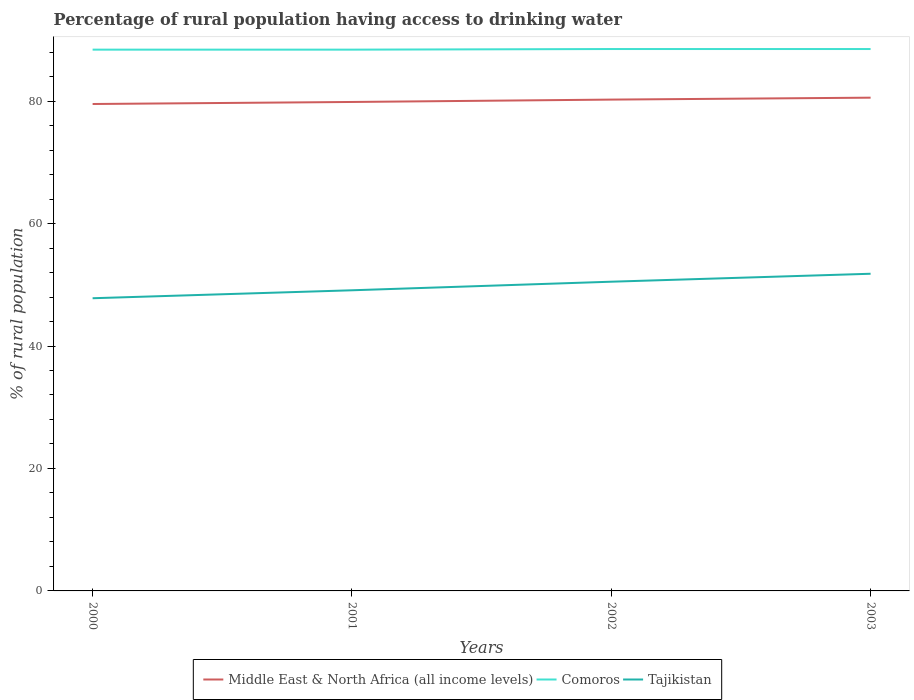Across all years, what is the maximum percentage of rural population having access to drinking water in Comoros?
Provide a succinct answer. 88.4. What is the total percentage of rural population having access to drinking water in Middle East & North Africa (all income levels) in the graph?
Offer a terse response. -0.7. What is the difference between the highest and the second highest percentage of rural population having access to drinking water in Middle East & North Africa (all income levels)?
Offer a terse response. 1.03. Is the percentage of rural population having access to drinking water in Comoros strictly greater than the percentage of rural population having access to drinking water in Middle East & North Africa (all income levels) over the years?
Your response must be concise. No. How many years are there in the graph?
Keep it short and to the point. 4. Are the values on the major ticks of Y-axis written in scientific E-notation?
Make the answer very short. No. Does the graph contain any zero values?
Offer a very short reply. No. Where does the legend appear in the graph?
Give a very brief answer. Bottom center. What is the title of the graph?
Ensure brevity in your answer.  Percentage of rural population having access to drinking water. What is the label or title of the X-axis?
Your answer should be compact. Years. What is the label or title of the Y-axis?
Give a very brief answer. % of rural population. What is the % of rural population of Middle East & North Africa (all income levels) in 2000?
Offer a very short reply. 79.52. What is the % of rural population in Comoros in 2000?
Provide a succinct answer. 88.4. What is the % of rural population in Tajikistan in 2000?
Give a very brief answer. 47.8. What is the % of rural population in Middle East & North Africa (all income levels) in 2001?
Give a very brief answer. 79.86. What is the % of rural population in Comoros in 2001?
Keep it short and to the point. 88.4. What is the % of rural population in Tajikistan in 2001?
Provide a short and direct response. 49.1. What is the % of rural population of Middle East & North Africa (all income levels) in 2002?
Make the answer very short. 80.24. What is the % of rural population of Comoros in 2002?
Your response must be concise. 88.5. What is the % of rural population in Tajikistan in 2002?
Offer a terse response. 50.5. What is the % of rural population of Middle East & North Africa (all income levels) in 2003?
Your answer should be very brief. 80.56. What is the % of rural population in Comoros in 2003?
Your answer should be very brief. 88.5. What is the % of rural population in Tajikistan in 2003?
Ensure brevity in your answer.  51.8. Across all years, what is the maximum % of rural population in Middle East & North Africa (all income levels)?
Ensure brevity in your answer.  80.56. Across all years, what is the maximum % of rural population of Comoros?
Provide a short and direct response. 88.5. Across all years, what is the maximum % of rural population in Tajikistan?
Provide a short and direct response. 51.8. Across all years, what is the minimum % of rural population of Middle East & North Africa (all income levels)?
Give a very brief answer. 79.52. Across all years, what is the minimum % of rural population in Comoros?
Your answer should be very brief. 88.4. Across all years, what is the minimum % of rural population of Tajikistan?
Make the answer very short. 47.8. What is the total % of rural population in Middle East & North Africa (all income levels) in the graph?
Ensure brevity in your answer.  320.18. What is the total % of rural population of Comoros in the graph?
Your answer should be very brief. 353.8. What is the total % of rural population of Tajikistan in the graph?
Provide a short and direct response. 199.2. What is the difference between the % of rural population of Middle East & North Africa (all income levels) in 2000 and that in 2001?
Your answer should be very brief. -0.33. What is the difference between the % of rural population of Tajikistan in 2000 and that in 2001?
Provide a short and direct response. -1.3. What is the difference between the % of rural population in Middle East & North Africa (all income levels) in 2000 and that in 2002?
Provide a succinct answer. -0.72. What is the difference between the % of rural population of Comoros in 2000 and that in 2002?
Give a very brief answer. -0.1. What is the difference between the % of rural population in Middle East & North Africa (all income levels) in 2000 and that in 2003?
Offer a terse response. -1.03. What is the difference between the % of rural population in Tajikistan in 2000 and that in 2003?
Give a very brief answer. -4. What is the difference between the % of rural population in Middle East & North Africa (all income levels) in 2001 and that in 2002?
Your answer should be very brief. -0.39. What is the difference between the % of rural population of Comoros in 2001 and that in 2002?
Keep it short and to the point. -0.1. What is the difference between the % of rural population in Tajikistan in 2001 and that in 2002?
Provide a succinct answer. -1.4. What is the difference between the % of rural population in Middle East & North Africa (all income levels) in 2001 and that in 2003?
Your answer should be very brief. -0.7. What is the difference between the % of rural population in Comoros in 2001 and that in 2003?
Your answer should be very brief. -0.1. What is the difference between the % of rural population of Middle East & North Africa (all income levels) in 2002 and that in 2003?
Keep it short and to the point. -0.31. What is the difference between the % of rural population in Middle East & North Africa (all income levels) in 2000 and the % of rural population in Comoros in 2001?
Give a very brief answer. -8.88. What is the difference between the % of rural population of Middle East & North Africa (all income levels) in 2000 and the % of rural population of Tajikistan in 2001?
Your answer should be very brief. 30.42. What is the difference between the % of rural population of Comoros in 2000 and the % of rural population of Tajikistan in 2001?
Offer a terse response. 39.3. What is the difference between the % of rural population in Middle East & North Africa (all income levels) in 2000 and the % of rural population in Comoros in 2002?
Keep it short and to the point. -8.98. What is the difference between the % of rural population in Middle East & North Africa (all income levels) in 2000 and the % of rural population in Tajikistan in 2002?
Your answer should be very brief. 29.02. What is the difference between the % of rural population in Comoros in 2000 and the % of rural population in Tajikistan in 2002?
Your response must be concise. 37.9. What is the difference between the % of rural population in Middle East & North Africa (all income levels) in 2000 and the % of rural population in Comoros in 2003?
Make the answer very short. -8.98. What is the difference between the % of rural population of Middle East & North Africa (all income levels) in 2000 and the % of rural population of Tajikistan in 2003?
Your answer should be very brief. 27.72. What is the difference between the % of rural population in Comoros in 2000 and the % of rural population in Tajikistan in 2003?
Offer a very short reply. 36.6. What is the difference between the % of rural population of Middle East & North Africa (all income levels) in 2001 and the % of rural population of Comoros in 2002?
Provide a succinct answer. -8.64. What is the difference between the % of rural population of Middle East & North Africa (all income levels) in 2001 and the % of rural population of Tajikistan in 2002?
Offer a terse response. 29.36. What is the difference between the % of rural population of Comoros in 2001 and the % of rural population of Tajikistan in 2002?
Ensure brevity in your answer.  37.9. What is the difference between the % of rural population of Middle East & North Africa (all income levels) in 2001 and the % of rural population of Comoros in 2003?
Make the answer very short. -8.64. What is the difference between the % of rural population in Middle East & North Africa (all income levels) in 2001 and the % of rural population in Tajikistan in 2003?
Your answer should be very brief. 28.06. What is the difference between the % of rural population in Comoros in 2001 and the % of rural population in Tajikistan in 2003?
Give a very brief answer. 36.6. What is the difference between the % of rural population of Middle East & North Africa (all income levels) in 2002 and the % of rural population of Comoros in 2003?
Provide a short and direct response. -8.26. What is the difference between the % of rural population of Middle East & North Africa (all income levels) in 2002 and the % of rural population of Tajikistan in 2003?
Provide a short and direct response. 28.44. What is the difference between the % of rural population in Comoros in 2002 and the % of rural population in Tajikistan in 2003?
Your answer should be compact. 36.7. What is the average % of rural population in Middle East & North Africa (all income levels) per year?
Provide a succinct answer. 80.04. What is the average % of rural population of Comoros per year?
Your answer should be very brief. 88.45. What is the average % of rural population of Tajikistan per year?
Your answer should be compact. 49.8. In the year 2000, what is the difference between the % of rural population of Middle East & North Africa (all income levels) and % of rural population of Comoros?
Keep it short and to the point. -8.88. In the year 2000, what is the difference between the % of rural population of Middle East & North Africa (all income levels) and % of rural population of Tajikistan?
Provide a succinct answer. 31.72. In the year 2000, what is the difference between the % of rural population in Comoros and % of rural population in Tajikistan?
Your answer should be very brief. 40.6. In the year 2001, what is the difference between the % of rural population in Middle East & North Africa (all income levels) and % of rural population in Comoros?
Your answer should be compact. -8.54. In the year 2001, what is the difference between the % of rural population in Middle East & North Africa (all income levels) and % of rural population in Tajikistan?
Your response must be concise. 30.76. In the year 2001, what is the difference between the % of rural population in Comoros and % of rural population in Tajikistan?
Provide a short and direct response. 39.3. In the year 2002, what is the difference between the % of rural population in Middle East & North Africa (all income levels) and % of rural population in Comoros?
Provide a succinct answer. -8.26. In the year 2002, what is the difference between the % of rural population of Middle East & North Africa (all income levels) and % of rural population of Tajikistan?
Keep it short and to the point. 29.74. In the year 2003, what is the difference between the % of rural population in Middle East & North Africa (all income levels) and % of rural population in Comoros?
Your response must be concise. -7.94. In the year 2003, what is the difference between the % of rural population in Middle East & North Africa (all income levels) and % of rural population in Tajikistan?
Provide a succinct answer. 28.76. In the year 2003, what is the difference between the % of rural population of Comoros and % of rural population of Tajikistan?
Ensure brevity in your answer.  36.7. What is the ratio of the % of rural population in Middle East & North Africa (all income levels) in 2000 to that in 2001?
Keep it short and to the point. 1. What is the ratio of the % of rural population of Tajikistan in 2000 to that in 2001?
Give a very brief answer. 0.97. What is the ratio of the % of rural population in Middle East & North Africa (all income levels) in 2000 to that in 2002?
Keep it short and to the point. 0.99. What is the ratio of the % of rural population of Tajikistan in 2000 to that in 2002?
Give a very brief answer. 0.95. What is the ratio of the % of rural population of Middle East & North Africa (all income levels) in 2000 to that in 2003?
Your answer should be very brief. 0.99. What is the ratio of the % of rural population of Comoros in 2000 to that in 2003?
Your response must be concise. 1. What is the ratio of the % of rural population in Tajikistan in 2000 to that in 2003?
Ensure brevity in your answer.  0.92. What is the ratio of the % of rural population of Middle East & North Africa (all income levels) in 2001 to that in 2002?
Provide a succinct answer. 1. What is the ratio of the % of rural population of Tajikistan in 2001 to that in 2002?
Give a very brief answer. 0.97. What is the ratio of the % of rural population in Middle East & North Africa (all income levels) in 2001 to that in 2003?
Your answer should be compact. 0.99. What is the ratio of the % of rural population of Comoros in 2001 to that in 2003?
Offer a very short reply. 1. What is the ratio of the % of rural population of Tajikistan in 2001 to that in 2003?
Your response must be concise. 0.95. What is the ratio of the % of rural population of Middle East & North Africa (all income levels) in 2002 to that in 2003?
Your response must be concise. 1. What is the ratio of the % of rural population of Tajikistan in 2002 to that in 2003?
Offer a terse response. 0.97. What is the difference between the highest and the second highest % of rural population in Middle East & North Africa (all income levels)?
Provide a short and direct response. 0.31. What is the difference between the highest and the lowest % of rural population in Middle East & North Africa (all income levels)?
Your answer should be very brief. 1.03. What is the difference between the highest and the lowest % of rural population of Comoros?
Give a very brief answer. 0.1. What is the difference between the highest and the lowest % of rural population of Tajikistan?
Your answer should be compact. 4. 